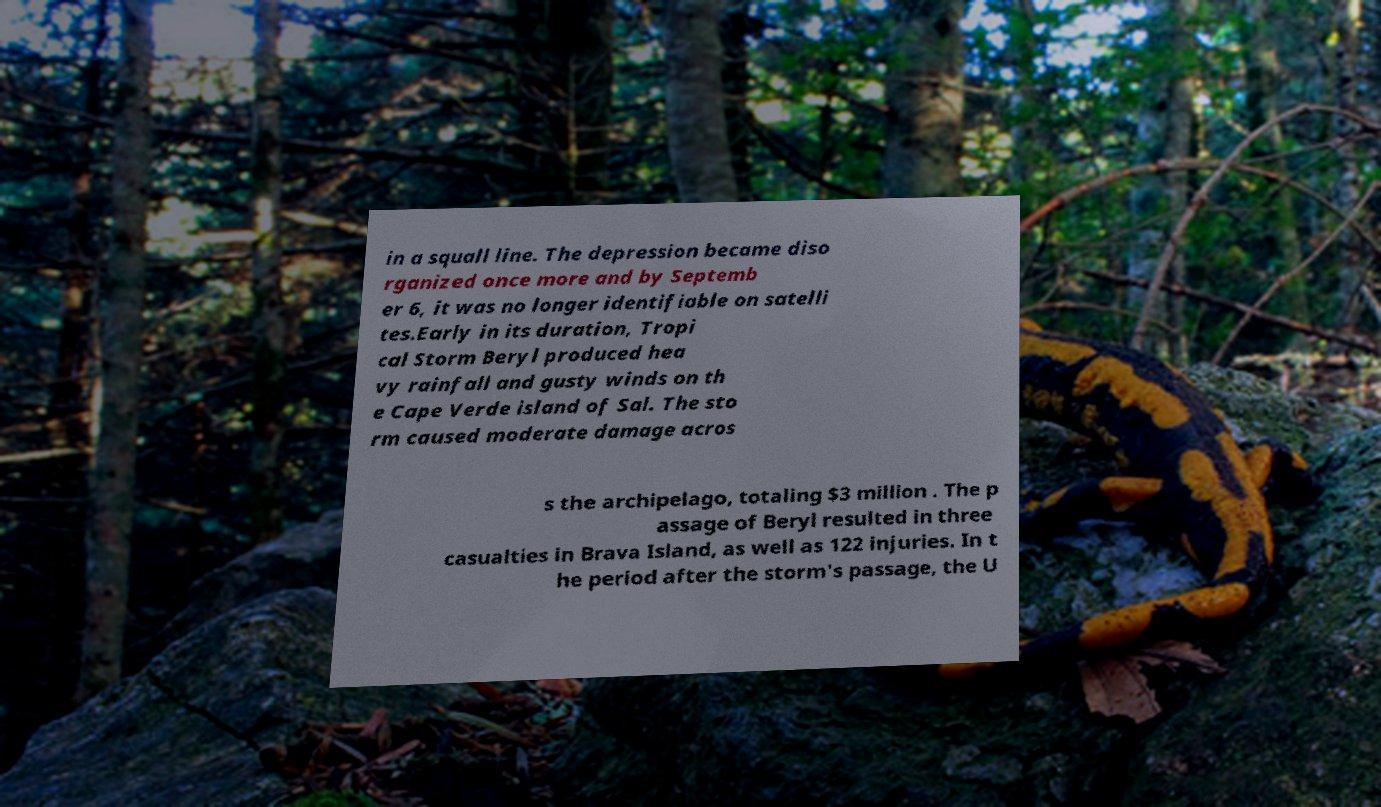Please read and relay the text visible in this image. What does it say? in a squall line. The depression became diso rganized once more and by Septemb er 6, it was no longer identifiable on satelli tes.Early in its duration, Tropi cal Storm Beryl produced hea vy rainfall and gusty winds on th e Cape Verde island of Sal. The sto rm caused moderate damage acros s the archipelago, totaling $3 million . The p assage of Beryl resulted in three casualties in Brava Island, as well as 122 injuries. In t he period after the storm's passage, the U 